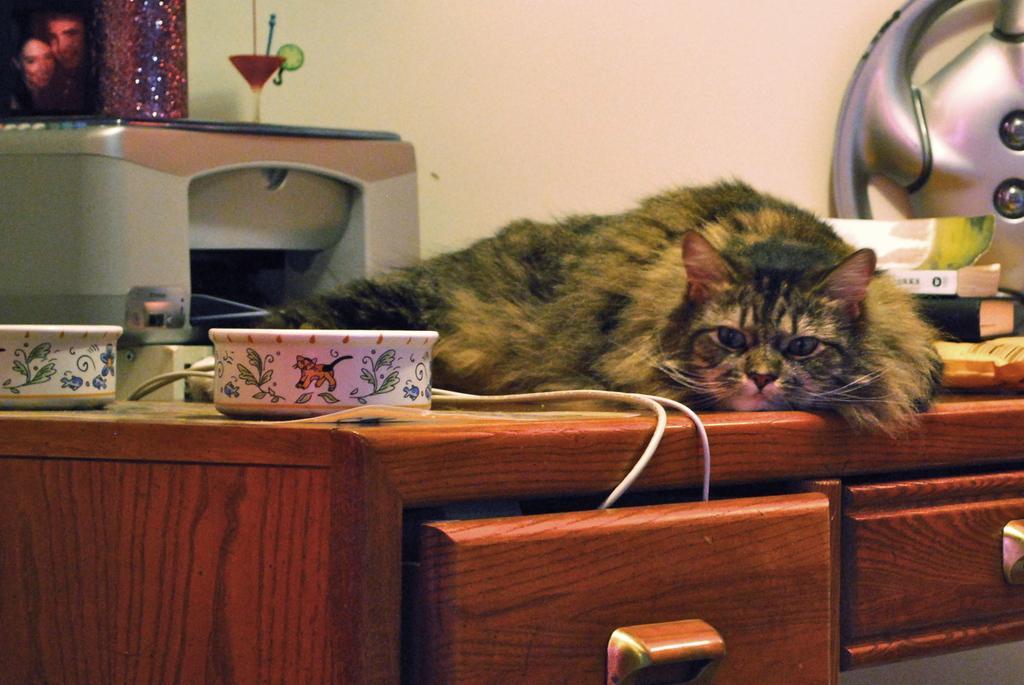Please provide a concise description of this image. A cat is lying on a table. There are two bowls,printed,books and other articles on the table. There are two drawers under the table. 